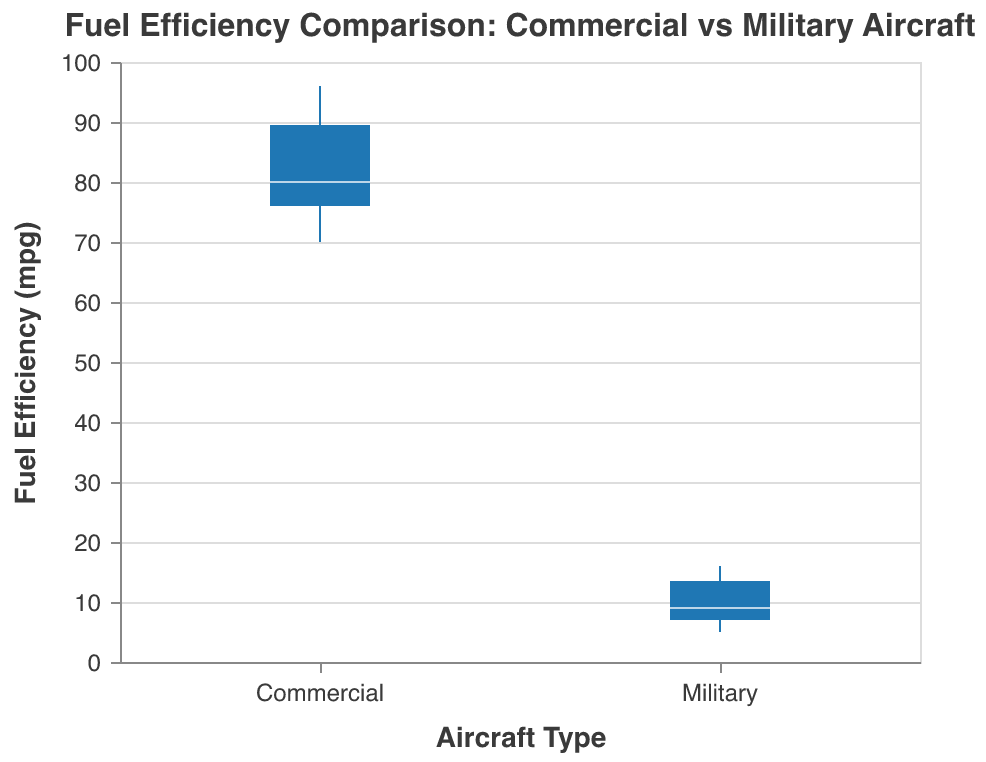What is the title of the plot? The title of the plot is displayed at the top and it reads "Fuel Efficiency Comparison: Commercial vs Military Aircraft."
Answer: Fuel Efficiency Comparison: Commercial vs Military Aircraft How many aircraft types are compared in the plot? The x-axis has two categories, "Commercial" and "Military," representing the two aircraft types being compared.
Answer: Two Which aircraft type has the higher range of fuel efficiency? By looking at the length of the boxplots along the y-axis, the "Commercial" aircraft type has the higher range, stretching from approximately 70 to 96 mpg compared to the "Military" aircraft type, which ranges from about 5 to 16 mpg.
Answer: Commercial What is the median fuel efficiency for commercial aircraft? The orange line in the boxplot represents the median. For commercial aircraft, it is roughly at 80 mpg.
Answer: 80 mpg What is the lowest recorded fuel efficiency for military aircraft? The bottom whisker of the "Military" boxplot extends to the lowest recorded value, which is 5 mpg.
Answer: 5 mpg Which aircraft type has the most outliers, if any, in the plot? There are no points marked as outliers (denoted usually by distinct markers outside the whiskers) in either of the boxplots for "Commercial" or "Military" aircraft.
Answer: None How does the median fuel efficiency of commercial aircraft compare to that of military aircraft? By comparing the orange lines, the median fuel efficiency for commercial aircraft (about 80 mpg) is significantly higher than that for military aircraft (around 9 mpg).
Answer: Higher What is the maximum fuel efficiency recorded for military aircraft? The top whisker of the "Military" boxplot indicates the maximum fuel efficiency, which is 16 mpg.
Answer: 16 mpg How does the dispersion of fuel efficiencies between commercial and military aircraft differ? The interquartile range (IQR) and whiskers indicate dispersion. The IQR for commercial aircraft is broader (approximately 70 to 96 mpg) compared to the military aircraft IQR (approximately 5 to 16 mpg), indicating more variability in commercial aircraft fuel efficiencies.
Answer: Commercial has more dispersion Are there any aircraft in the plot with fuel efficiency less than 10 mpg? By observing the whiskers and the data range, all the aircraft in the "Military" category have fuel efficiency values that include less than 10 mpg, visible at the lower end of the whiskers.
Answer: Yes 